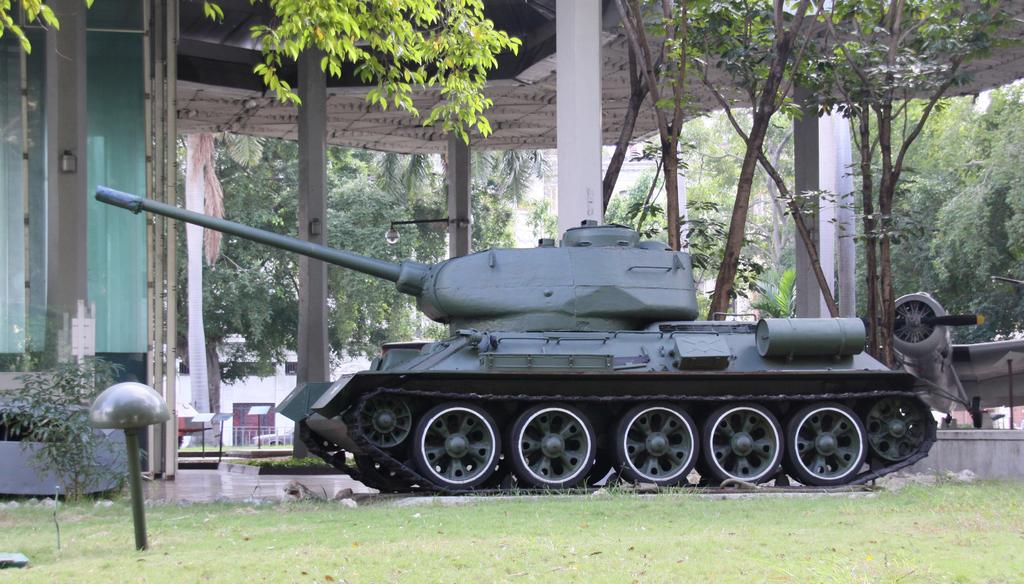What is the primary vegetation covering the land in the image? The land is covered with grass in the image. What type of vehicle can be seen in the image? There is a military vehicle in the image. What other mode of transportation is present in the image? There is a plane in the image. What can be seen in the background of the image? There are trees, an open-shed, pillars, light, information boards, and plants in the background of the image. What type of structure is present in the image? There is a glass wall in the image. Are there any bears visible in the image? No, there are no bears present in the image. What type of pump can be seen in the background of the image? There is no pump visible in the image. 